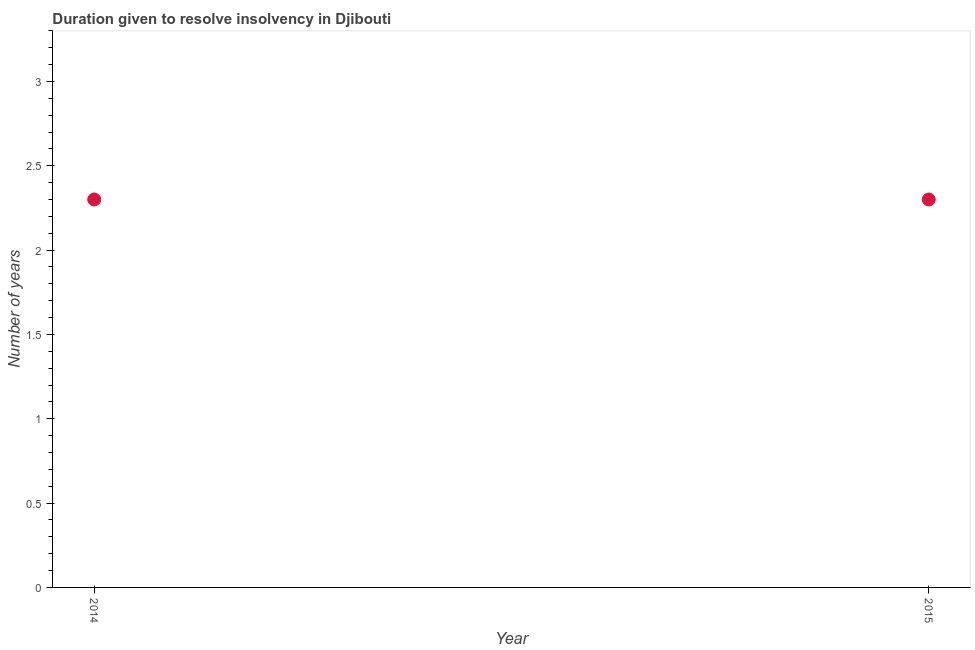In which year was the number of years to resolve insolvency maximum?
Your answer should be very brief. 2014. In which year was the number of years to resolve insolvency minimum?
Your response must be concise. 2014. What is the sum of the number of years to resolve insolvency?
Give a very brief answer. 4.6. What is the difference between the number of years to resolve insolvency in 2014 and 2015?
Keep it short and to the point. 0. What is the average number of years to resolve insolvency per year?
Make the answer very short. 2.3. In how many years, is the number of years to resolve insolvency greater than 0.9 ?
Ensure brevity in your answer.  2. Do a majority of the years between 2015 and 2014 (inclusive) have number of years to resolve insolvency greater than 0.1 ?
Keep it short and to the point. No. What is the ratio of the number of years to resolve insolvency in 2014 to that in 2015?
Offer a terse response. 1. In how many years, is the number of years to resolve insolvency greater than the average number of years to resolve insolvency taken over all years?
Provide a succinct answer. 0. Does the number of years to resolve insolvency monotonically increase over the years?
Your answer should be very brief. No. How many dotlines are there?
Offer a terse response. 1. Are the values on the major ticks of Y-axis written in scientific E-notation?
Provide a succinct answer. No. Does the graph contain grids?
Give a very brief answer. No. What is the title of the graph?
Make the answer very short. Duration given to resolve insolvency in Djibouti. What is the label or title of the Y-axis?
Provide a succinct answer. Number of years. What is the Number of years in 2014?
Make the answer very short. 2.3. What is the difference between the Number of years in 2014 and 2015?
Keep it short and to the point. 0. What is the ratio of the Number of years in 2014 to that in 2015?
Provide a succinct answer. 1. 